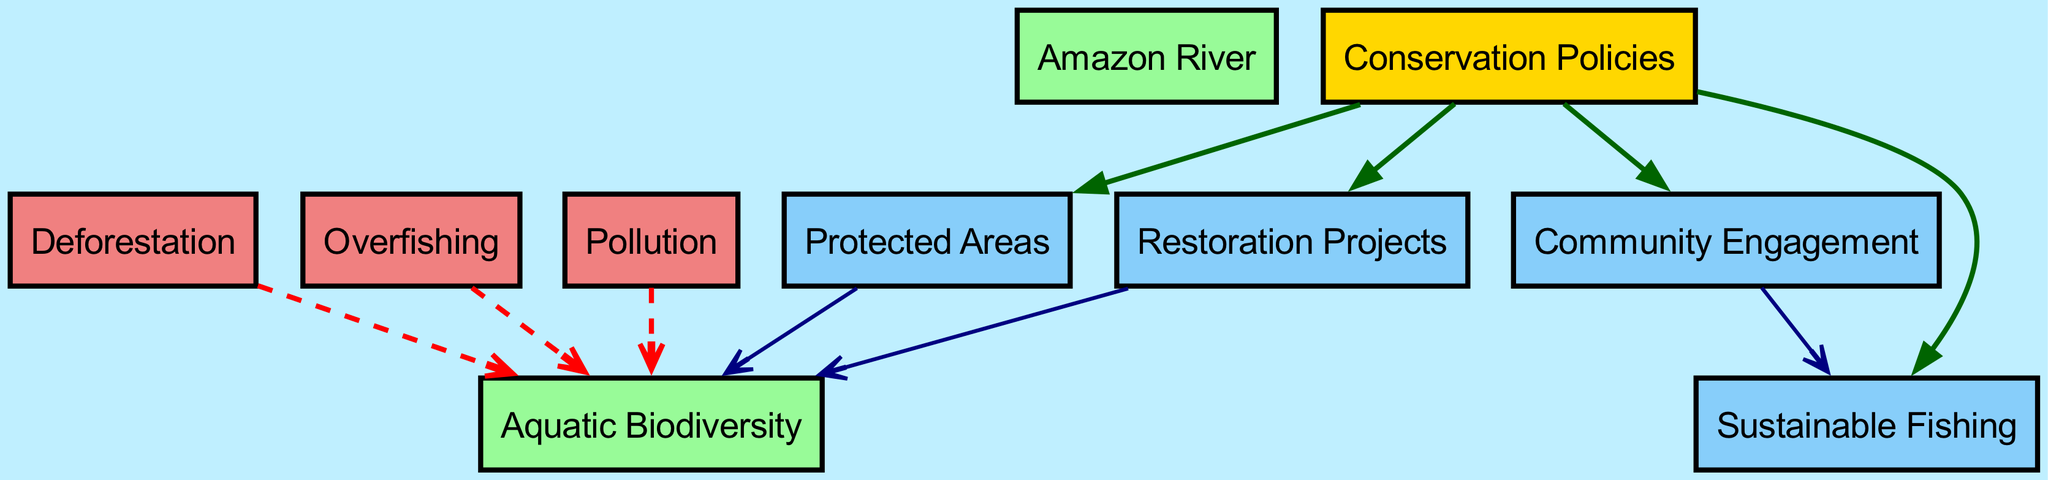What is the total number of nodes in the diagram? The diagram contains 10 distinct nodes, which are listed in the data: Amazon River, Aquatic Biodiversity, Deforestation, Overfishing, Pollution, Conservation Policies, Protected Areas, Community Engagement, Sustainable Fishing, and Restoration Projects.
Answer: 10 Which node has the most incoming edges? By examining the directed edges, Aquatic Biodiversity has three incoming edges, coming from Deforestation, Overfishing, and Pollution, indicating it is affected by these negative factors.
Answer: Aquatic Biodiversity What is the relationship between Conservation Policies and Protected Areas? The edge from Conservation Policies to Protected Areas indicates a direct relationship where Conservation Policies promote or lead to the establishment of Protected Areas.
Answer: Promotes How many forms of conservation efforts are present in the diagram? The diagram shows four forms of conservation efforts connected to Conservation Policies: Protected Areas, Community Engagement, Sustainable Fishing, and Restoration Projects, making a total of four distinct efforts.
Answer: 4 What color represents the negative impacts in the diagram? The nodes that represent negative impacts (Deforestation, Overfishing, and Pollution) are shown in light coral, indicating their harmful effects on aquatic biodiversity.
Answer: Light coral How does Community Engagement influence Sustainable Fishing? The directed edge from Community Engagement to Sustainable Fishing demonstrates that higher community engagement is positively influencing the use of sustainable fishing practices in the Amazon basin.
Answer: Positively influences What type of relationship do Conservation Policies have with its connected nodes? All edges leading from Conservation Policies to its connected nodes (Protected Areas, Community Engagement, Sustainable Fishing, Restoration Projects) indicate a supportive or positive influence, as they are shown in dark green.
Answer: Supportive Which node is the main subject of the diagram? The main subject of the diagram is Aquatic Biodiversity, as it directly connects to multiple factors, especially those that influence its health and numbers in the Amazon River ecosystem.
Answer: Aquatic Biodiversity 